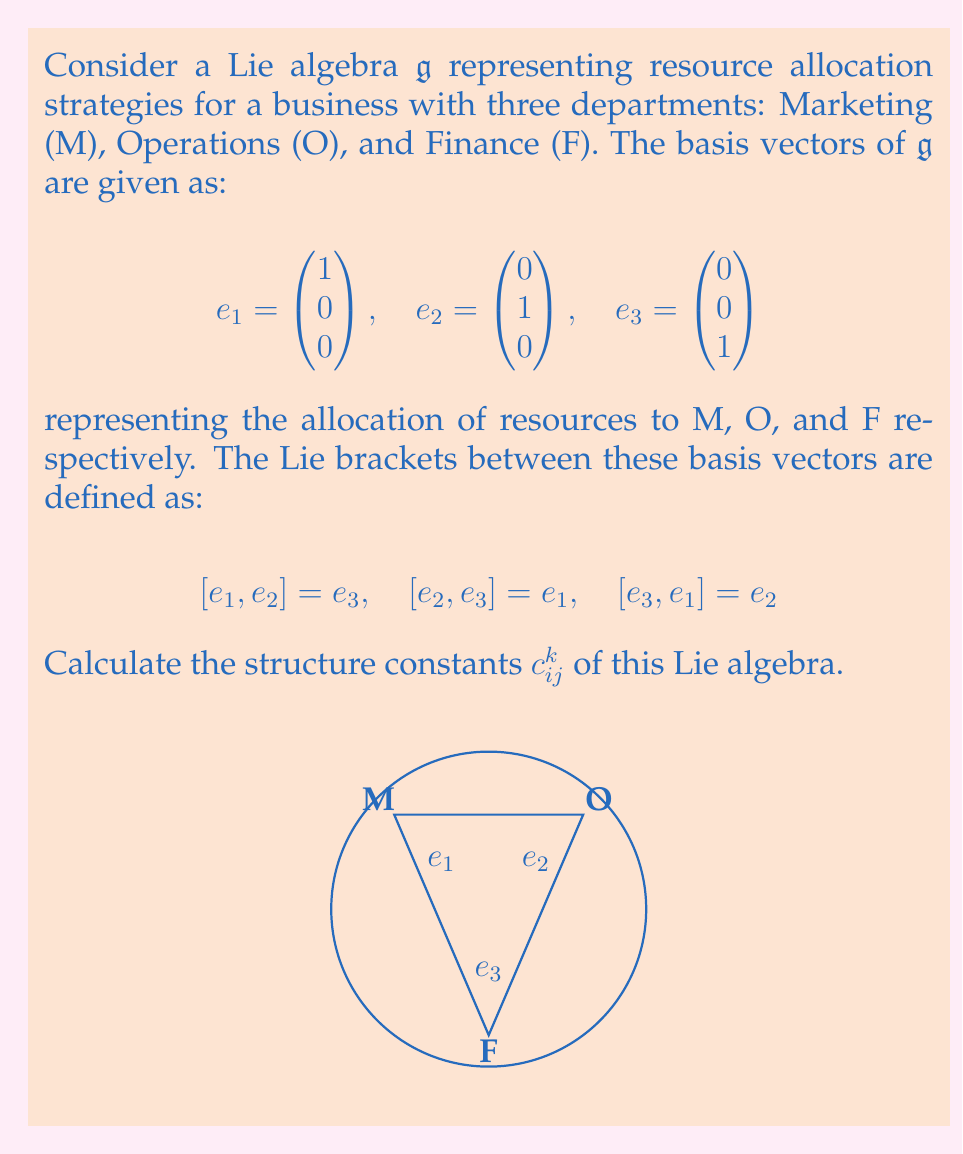Teach me how to tackle this problem. To calculate the structure constants $c_{ij}^k$ of the Lie algebra, we need to express each Lie bracket in terms of the structure constants and the basis vectors:

$$[e_i, e_j] = \sum_{k=1}^3 c_{ij}^k e_k$$

Step 1: Express $[e_1, e_2] = e_3$
$$[e_1, e_2] = c_{12}^1 e_1 + c_{12}^2 e_2 + c_{12}^3 e_3 = e_3$$
Therefore, $c_{12}^1 = 0$, $c_{12}^2 = 0$, and $c_{12}^3 = 1$

Step 2: Express $[e_2, e_3] = e_1$
$$[e_2, e_3] = c_{23}^1 e_1 + c_{23}^2 e_2 + c_{23}^3 e_3 = e_1$$
Therefore, $c_{23}^1 = 1$, $c_{23}^2 = 0$, and $c_{23}^3 = 0$

Step 3: Express $[e_3, e_1] = e_2$
$$[e_3, e_1] = c_{31}^1 e_1 + c_{31}^2 e_2 + c_{31}^3 e_3 = e_2$$
Therefore, $c_{31}^1 = 0$, $c_{31}^2 = 1$, and $c_{31}^3 = 0$

Step 4: Use the antisymmetry property of Lie brackets
$$[e_i, e_j] = -[e_j, e_i]$$
This implies:
$c_{21}^k = -c_{12}^k$, $c_{32}^k = -c_{23}^k$, $c_{13}^k = -c_{31}^k$

Step 5: Fill in the remaining structure constants
$c_{21}^1 = 0$, $c_{21}^2 = 0$, $c_{21}^3 = -1$
$c_{32}^1 = -1$, $c_{32}^2 = 0$, $c_{32}^3 = 0$
$c_{13}^1 = 0$, $c_{13}^2 = -1$, $c_{13}^3 = 0$

All other structure constants are zero.
Answer: $c_{12}^3 = c_{23}^1 = c_{31}^2 = 1$, $c_{21}^3 = c_{32}^1 = c_{13}^2 = -1$, all others $= 0$ 